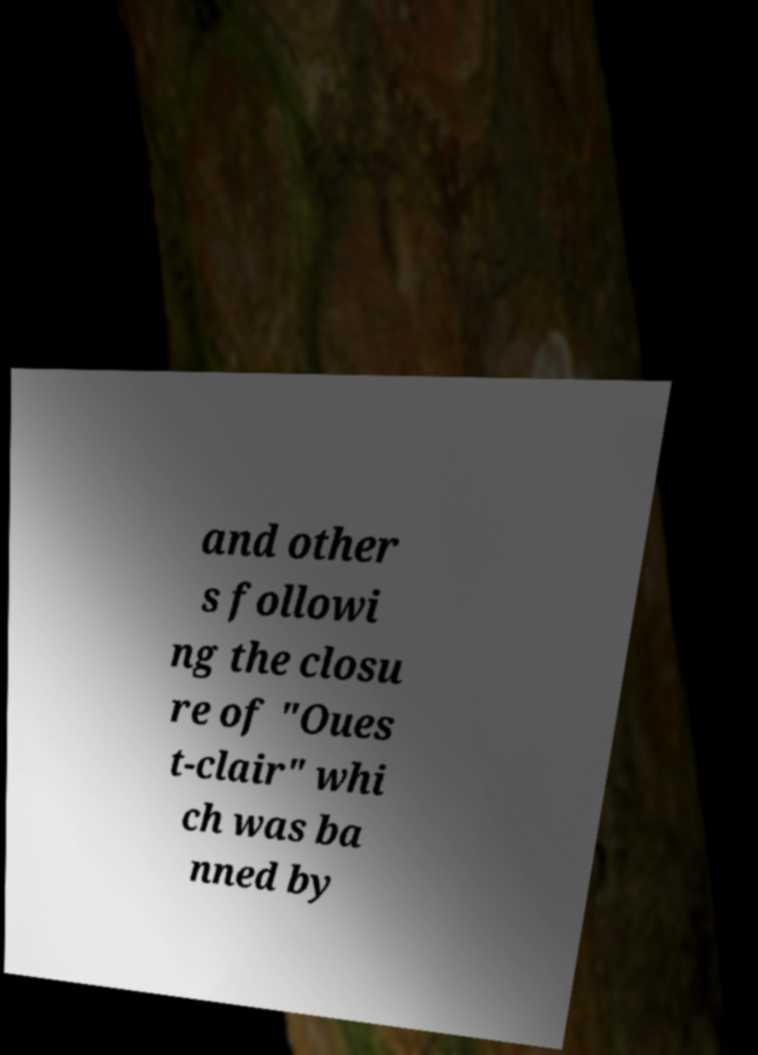There's text embedded in this image that I need extracted. Can you transcribe it verbatim? and other s followi ng the closu re of "Oues t-clair" whi ch was ba nned by 